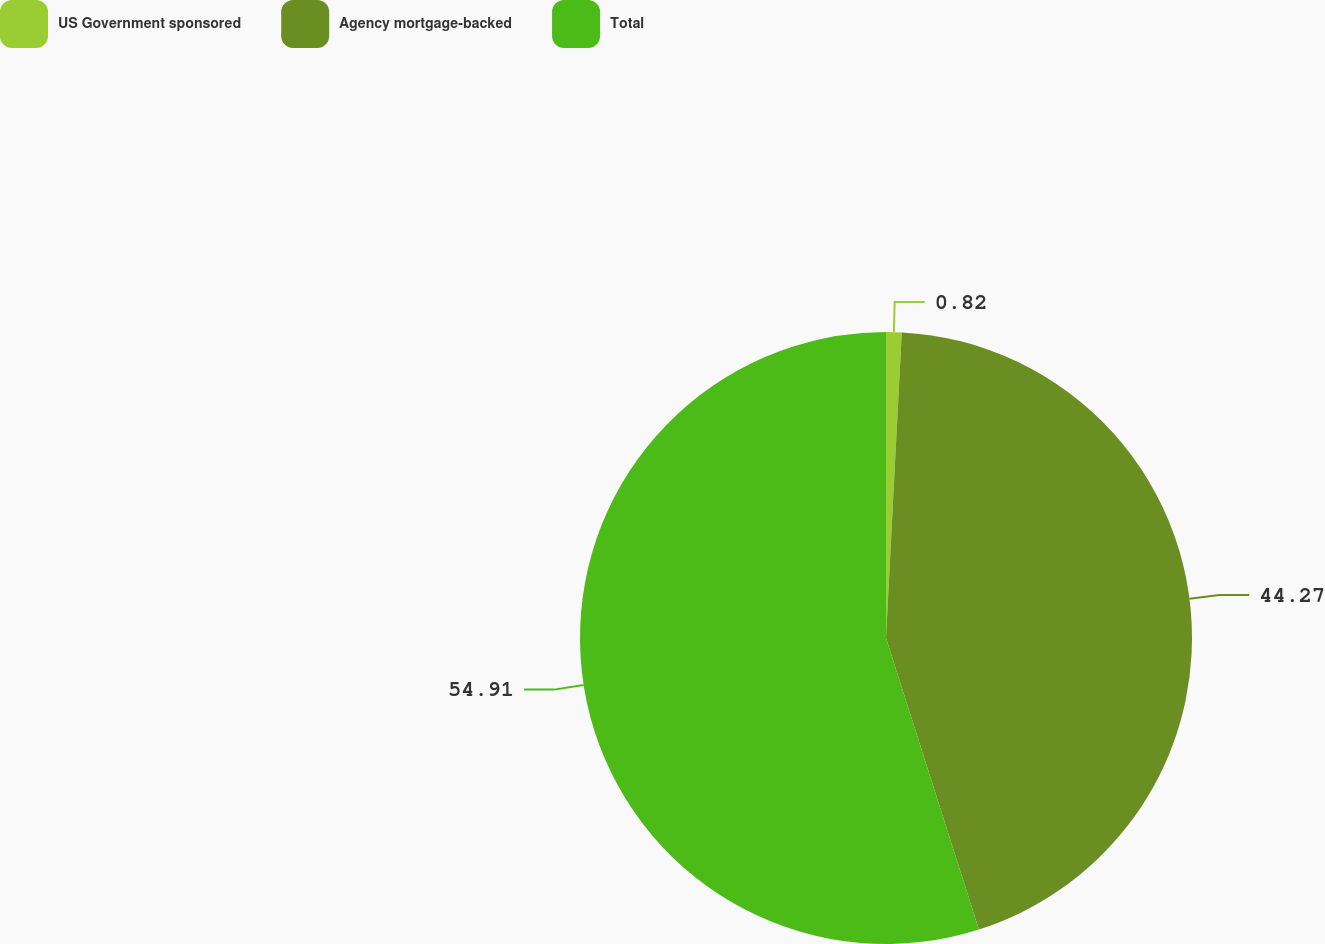Convert chart. <chart><loc_0><loc_0><loc_500><loc_500><pie_chart><fcel>US Government sponsored<fcel>Agency mortgage-backed<fcel>Total<nl><fcel>0.82%<fcel>44.27%<fcel>54.91%<nl></chart> 